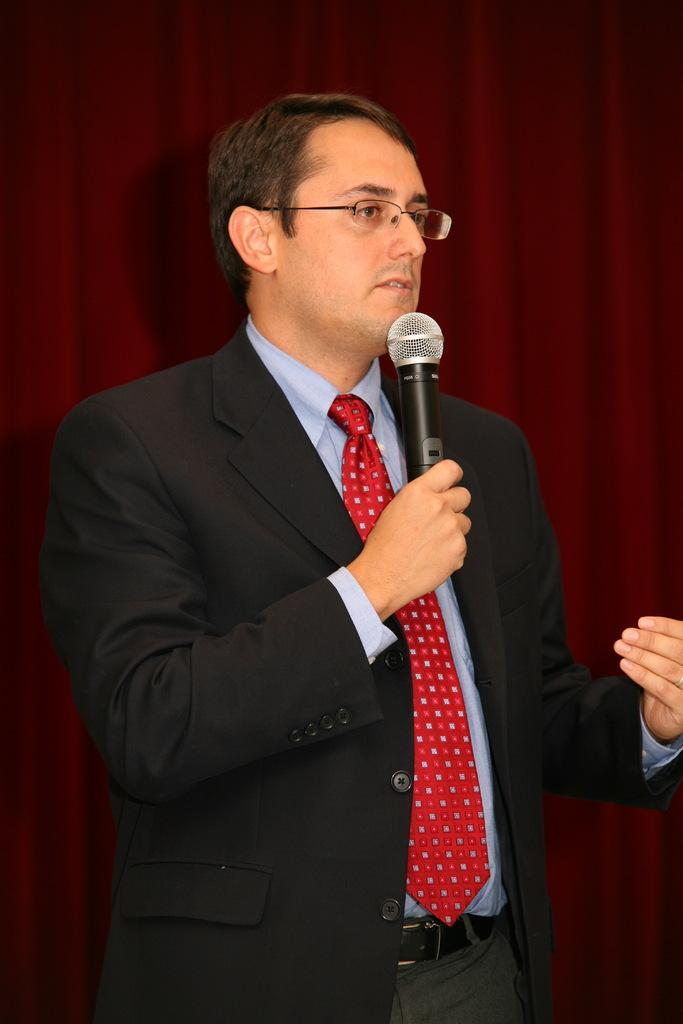What is the man in the image doing? The man is standing in the image and holding a microphone in his hand. What color is the cloth in the background of the image? The cloth in the background of the image is maroon in color. Can you see any cream on the man's face in the image? There is no mention of cream on the man's face in the image, so we cannot determine its presence. 